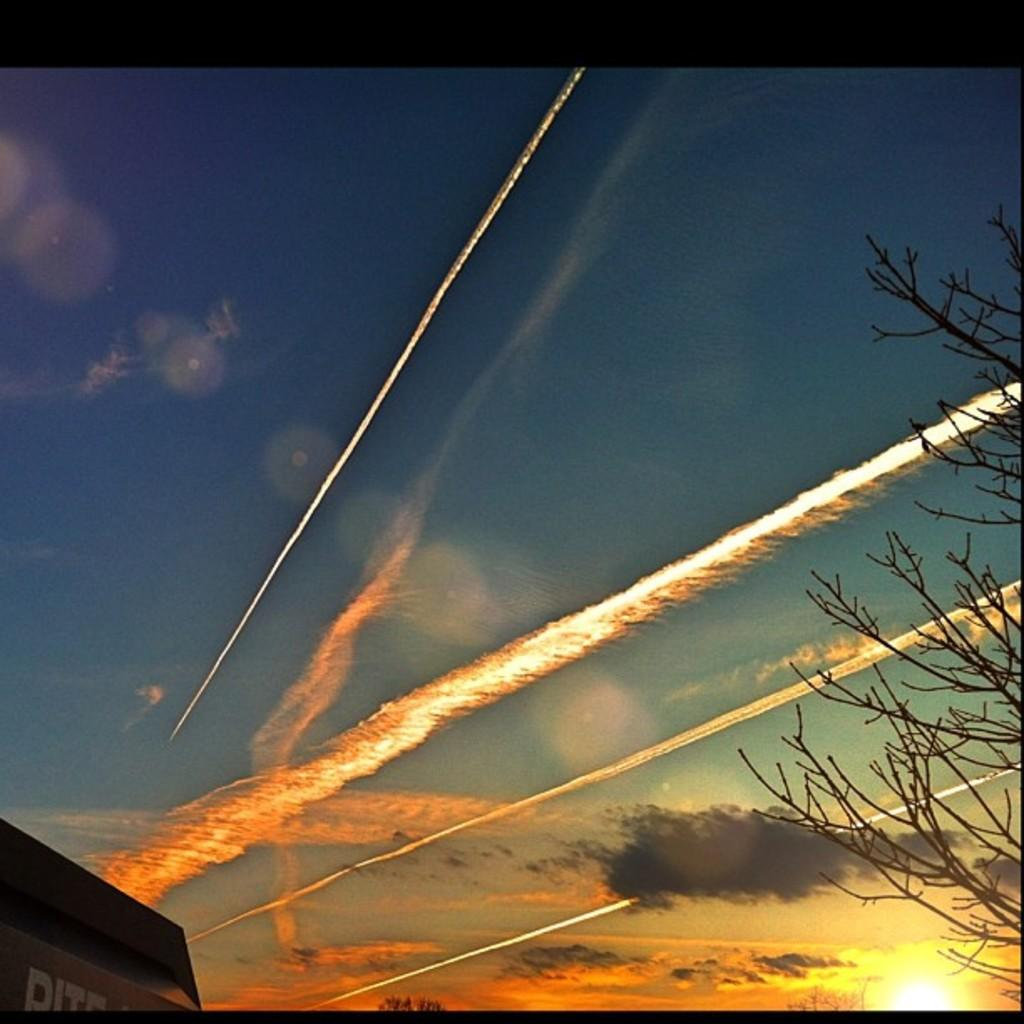What type of vegetation is on the right side of the image? There is a dry tree on the right side of the image. What is written or displayed on the board in the image? There is a board with text on the left side of the image. How would you describe the sky in the image? The sky is cloudy in the image. Can you see the sea in the image? No, there is no sea visible in the image. What type of cup is being used to collect rainwater in the image? There is no cup or rainwater present in the image. 